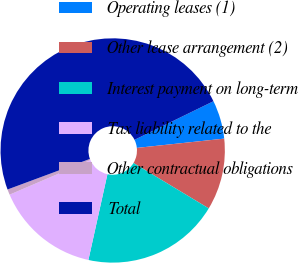Convert chart to OTSL. <chart><loc_0><loc_0><loc_500><loc_500><pie_chart><fcel>Operating leases (1)<fcel>Other lease arrangement (2)<fcel>Interest payment on long-term<fcel>Tax liability related to the<fcel>Other contractual obligations<fcel>Total<nl><fcel>5.55%<fcel>10.32%<fcel>19.84%<fcel>15.08%<fcel>0.79%<fcel>48.42%<nl></chart> 